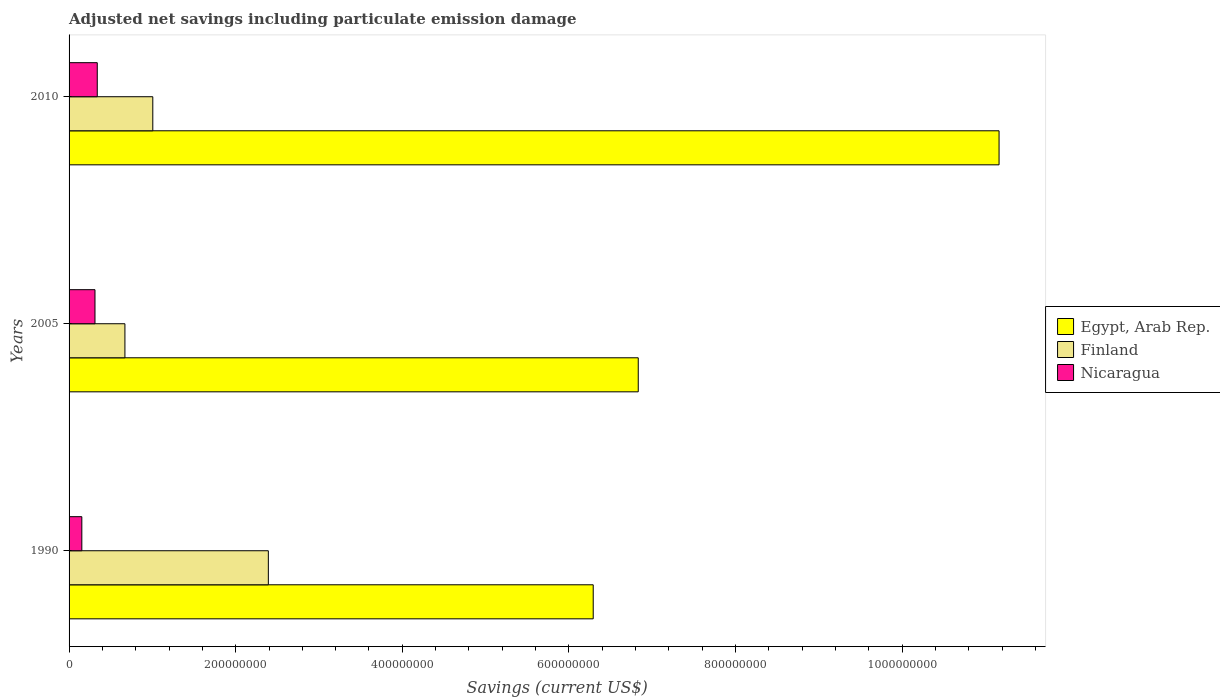Are the number of bars on each tick of the Y-axis equal?
Make the answer very short. Yes. How many bars are there on the 2nd tick from the bottom?
Make the answer very short. 3. In how many cases, is the number of bars for a given year not equal to the number of legend labels?
Give a very brief answer. 0. What is the net savings in Nicaragua in 2010?
Your response must be concise. 3.38e+07. Across all years, what is the maximum net savings in Egypt, Arab Rep.?
Offer a terse response. 1.12e+09. Across all years, what is the minimum net savings in Nicaragua?
Provide a short and direct response. 1.53e+07. In which year was the net savings in Egypt, Arab Rep. minimum?
Offer a very short reply. 1990. What is the total net savings in Egypt, Arab Rep. in the graph?
Your answer should be compact. 2.43e+09. What is the difference between the net savings in Finland in 2005 and that in 2010?
Make the answer very short. -3.35e+07. What is the difference between the net savings in Finland in 1990 and the net savings in Nicaragua in 2005?
Make the answer very short. 2.08e+08. What is the average net savings in Nicaragua per year?
Give a very brief answer. 2.68e+07. In the year 2005, what is the difference between the net savings in Egypt, Arab Rep. and net savings in Finland?
Your response must be concise. 6.16e+08. What is the ratio of the net savings in Egypt, Arab Rep. in 1990 to that in 2005?
Ensure brevity in your answer.  0.92. Is the difference between the net savings in Egypt, Arab Rep. in 1990 and 2005 greater than the difference between the net savings in Finland in 1990 and 2005?
Make the answer very short. No. What is the difference between the highest and the second highest net savings in Egypt, Arab Rep.?
Your answer should be very brief. 4.33e+08. What is the difference between the highest and the lowest net savings in Finland?
Ensure brevity in your answer.  1.72e+08. In how many years, is the net savings in Finland greater than the average net savings in Finland taken over all years?
Provide a succinct answer. 1. What does the 3rd bar from the top in 2005 represents?
Your answer should be very brief. Egypt, Arab Rep. What does the 3rd bar from the bottom in 2010 represents?
Provide a short and direct response. Nicaragua. Is it the case that in every year, the sum of the net savings in Finland and net savings in Egypt, Arab Rep. is greater than the net savings in Nicaragua?
Keep it short and to the point. Yes. Are all the bars in the graph horizontal?
Offer a terse response. Yes. Does the graph contain grids?
Provide a succinct answer. No. Where does the legend appear in the graph?
Provide a succinct answer. Center right. What is the title of the graph?
Your response must be concise. Adjusted net savings including particulate emission damage. What is the label or title of the X-axis?
Your answer should be very brief. Savings (current US$). What is the Savings (current US$) in Egypt, Arab Rep. in 1990?
Your answer should be compact. 6.29e+08. What is the Savings (current US$) in Finland in 1990?
Give a very brief answer. 2.39e+08. What is the Savings (current US$) of Nicaragua in 1990?
Your answer should be very brief. 1.53e+07. What is the Savings (current US$) of Egypt, Arab Rep. in 2005?
Keep it short and to the point. 6.83e+08. What is the Savings (current US$) in Finland in 2005?
Ensure brevity in your answer.  6.70e+07. What is the Savings (current US$) of Nicaragua in 2005?
Your response must be concise. 3.11e+07. What is the Savings (current US$) in Egypt, Arab Rep. in 2010?
Your answer should be compact. 1.12e+09. What is the Savings (current US$) in Finland in 2010?
Your answer should be very brief. 1.01e+08. What is the Savings (current US$) of Nicaragua in 2010?
Ensure brevity in your answer.  3.38e+07. Across all years, what is the maximum Savings (current US$) of Egypt, Arab Rep.?
Ensure brevity in your answer.  1.12e+09. Across all years, what is the maximum Savings (current US$) of Finland?
Keep it short and to the point. 2.39e+08. Across all years, what is the maximum Savings (current US$) of Nicaragua?
Offer a very short reply. 3.38e+07. Across all years, what is the minimum Savings (current US$) of Egypt, Arab Rep.?
Your answer should be very brief. 6.29e+08. Across all years, what is the minimum Savings (current US$) in Finland?
Keep it short and to the point. 6.70e+07. Across all years, what is the minimum Savings (current US$) of Nicaragua?
Your answer should be very brief. 1.53e+07. What is the total Savings (current US$) of Egypt, Arab Rep. in the graph?
Ensure brevity in your answer.  2.43e+09. What is the total Savings (current US$) in Finland in the graph?
Give a very brief answer. 4.07e+08. What is the total Savings (current US$) in Nicaragua in the graph?
Offer a terse response. 8.03e+07. What is the difference between the Savings (current US$) in Egypt, Arab Rep. in 1990 and that in 2005?
Offer a terse response. -5.41e+07. What is the difference between the Savings (current US$) in Finland in 1990 and that in 2005?
Offer a terse response. 1.72e+08. What is the difference between the Savings (current US$) of Nicaragua in 1990 and that in 2005?
Provide a short and direct response. -1.58e+07. What is the difference between the Savings (current US$) of Egypt, Arab Rep. in 1990 and that in 2010?
Your response must be concise. -4.87e+08. What is the difference between the Savings (current US$) in Finland in 1990 and that in 2010?
Offer a terse response. 1.39e+08. What is the difference between the Savings (current US$) in Nicaragua in 1990 and that in 2010?
Make the answer very short. -1.85e+07. What is the difference between the Savings (current US$) in Egypt, Arab Rep. in 2005 and that in 2010?
Ensure brevity in your answer.  -4.33e+08. What is the difference between the Savings (current US$) of Finland in 2005 and that in 2010?
Your response must be concise. -3.35e+07. What is the difference between the Savings (current US$) of Nicaragua in 2005 and that in 2010?
Make the answer very short. -2.74e+06. What is the difference between the Savings (current US$) of Egypt, Arab Rep. in 1990 and the Savings (current US$) of Finland in 2005?
Keep it short and to the point. 5.62e+08. What is the difference between the Savings (current US$) of Egypt, Arab Rep. in 1990 and the Savings (current US$) of Nicaragua in 2005?
Your answer should be compact. 5.98e+08. What is the difference between the Savings (current US$) in Finland in 1990 and the Savings (current US$) in Nicaragua in 2005?
Make the answer very short. 2.08e+08. What is the difference between the Savings (current US$) in Egypt, Arab Rep. in 1990 and the Savings (current US$) in Finland in 2010?
Give a very brief answer. 5.29e+08. What is the difference between the Savings (current US$) in Egypt, Arab Rep. in 1990 and the Savings (current US$) in Nicaragua in 2010?
Offer a very short reply. 5.95e+08. What is the difference between the Savings (current US$) of Finland in 1990 and the Savings (current US$) of Nicaragua in 2010?
Keep it short and to the point. 2.05e+08. What is the difference between the Savings (current US$) in Egypt, Arab Rep. in 2005 and the Savings (current US$) in Finland in 2010?
Your answer should be compact. 5.83e+08. What is the difference between the Savings (current US$) of Egypt, Arab Rep. in 2005 and the Savings (current US$) of Nicaragua in 2010?
Your response must be concise. 6.49e+08. What is the difference between the Savings (current US$) in Finland in 2005 and the Savings (current US$) in Nicaragua in 2010?
Your response must be concise. 3.32e+07. What is the average Savings (current US$) of Egypt, Arab Rep. per year?
Keep it short and to the point. 8.10e+08. What is the average Savings (current US$) of Finland per year?
Your response must be concise. 1.36e+08. What is the average Savings (current US$) in Nicaragua per year?
Your answer should be compact. 2.68e+07. In the year 1990, what is the difference between the Savings (current US$) in Egypt, Arab Rep. and Savings (current US$) in Finland?
Your answer should be very brief. 3.90e+08. In the year 1990, what is the difference between the Savings (current US$) in Egypt, Arab Rep. and Savings (current US$) in Nicaragua?
Your answer should be very brief. 6.14e+08. In the year 1990, what is the difference between the Savings (current US$) in Finland and Savings (current US$) in Nicaragua?
Your answer should be very brief. 2.24e+08. In the year 2005, what is the difference between the Savings (current US$) in Egypt, Arab Rep. and Savings (current US$) in Finland?
Give a very brief answer. 6.16e+08. In the year 2005, what is the difference between the Savings (current US$) in Egypt, Arab Rep. and Savings (current US$) in Nicaragua?
Give a very brief answer. 6.52e+08. In the year 2005, what is the difference between the Savings (current US$) in Finland and Savings (current US$) in Nicaragua?
Make the answer very short. 3.59e+07. In the year 2010, what is the difference between the Savings (current US$) of Egypt, Arab Rep. and Savings (current US$) of Finland?
Offer a terse response. 1.02e+09. In the year 2010, what is the difference between the Savings (current US$) of Egypt, Arab Rep. and Savings (current US$) of Nicaragua?
Your answer should be very brief. 1.08e+09. In the year 2010, what is the difference between the Savings (current US$) of Finland and Savings (current US$) of Nicaragua?
Keep it short and to the point. 6.67e+07. What is the ratio of the Savings (current US$) of Egypt, Arab Rep. in 1990 to that in 2005?
Your answer should be compact. 0.92. What is the ratio of the Savings (current US$) of Finland in 1990 to that in 2005?
Keep it short and to the point. 3.57. What is the ratio of the Savings (current US$) of Nicaragua in 1990 to that in 2005?
Ensure brevity in your answer.  0.49. What is the ratio of the Savings (current US$) in Egypt, Arab Rep. in 1990 to that in 2010?
Offer a terse response. 0.56. What is the ratio of the Savings (current US$) in Finland in 1990 to that in 2010?
Provide a succinct answer. 2.38. What is the ratio of the Savings (current US$) of Nicaragua in 1990 to that in 2010?
Offer a very short reply. 0.45. What is the ratio of the Savings (current US$) in Egypt, Arab Rep. in 2005 to that in 2010?
Offer a very short reply. 0.61. What is the ratio of the Savings (current US$) in Finland in 2005 to that in 2010?
Your answer should be compact. 0.67. What is the ratio of the Savings (current US$) of Nicaragua in 2005 to that in 2010?
Your answer should be very brief. 0.92. What is the difference between the highest and the second highest Savings (current US$) in Egypt, Arab Rep.?
Give a very brief answer. 4.33e+08. What is the difference between the highest and the second highest Savings (current US$) in Finland?
Make the answer very short. 1.39e+08. What is the difference between the highest and the second highest Savings (current US$) of Nicaragua?
Ensure brevity in your answer.  2.74e+06. What is the difference between the highest and the lowest Savings (current US$) in Egypt, Arab Rep.?
Your answer should be compact. 4.87e+08. What is the difference between the highest and the lowest Savings (current US$) in Finland?
Provide a short and direct response. 1.72e+08. What is the difference between the highest and the lowest Savings (current US$) in Nicaragua?
Provide a short and direct response. 1.85e+07. 